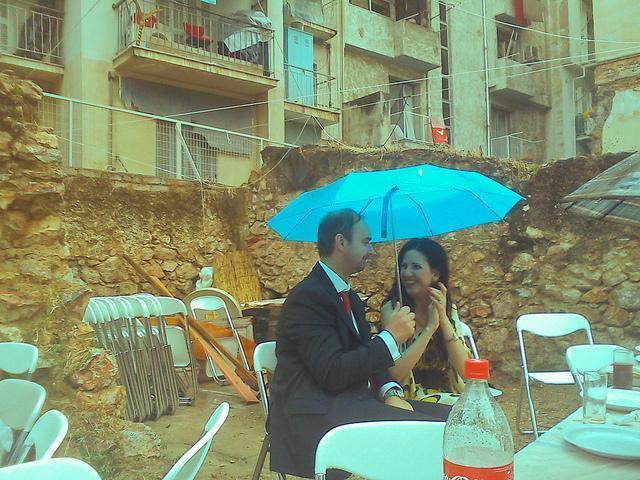How many people are there?
Give a very brief answer. 2. How many chairs are there?
Give a very brief answer. 4. 